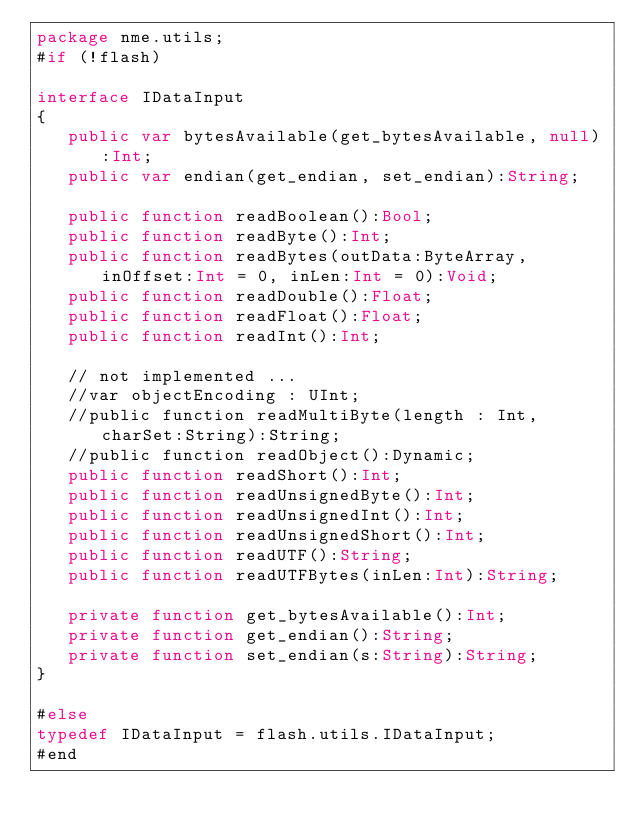<code> <loc_0><loc_0><loc_500><loc_500><_Haxe_>package nme.utils;
#if (!flash)

interface IDataInput 
{
   public var bytesAvailable(get_bytesAvailable, null):Int;
   public var endian(get_endian, set_endian):String;

   public function readBoolean():Bool;
   public function readByte():Int;
   public function readBytes(outData:ByteArray, inOffset:Int = 0, inLen:Int = 0):Void;
   public function readDouble():Float;
   public function readFloat():Float;
   public function readInt():Int;

   // not implemented ...
   //var objectEncoding : UInt;
   //public function readMultiByte(length : Int, charSet:String):String;
   //public function readObject():Dynamic;
   public function readShort():Int;
   public function readUnsignedByte():Int;
   public function readUnsignedInt():Int;
   public function readUnsignedShort():Int;
   public function readUTF():String;
   public function readUTFBytes(inLen:Int):String;

   private function get_bytesAvailable():Int;
   private function get_endian():String;
   private function set_endian(s:String):String;
}

#else
typedef IDataInput = flash.utils.IDataInput;
#end
</code> 